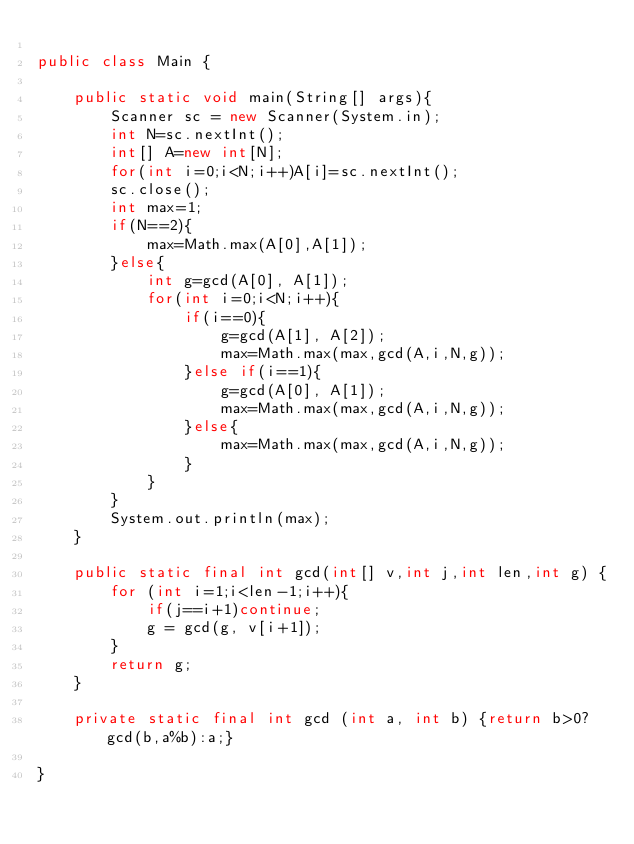<code> <loc_0><loc_0><loc_500><loc_500><_Java_>
public class Main {

	public static void main(String[] args){
		Scanner sc = new Scanner(System.in);
		int N=sc.nextInt();
		int[] A=new int[N];
		for(int i=0;i<N;i++)A[i]=sc.nextInt();
		sc.close();
		int max=1;
		if(N==2){
			max=Math.max(A[0],A[1]);
		}else{
			int g=gcd(A[0], A[1]);
			for(int i=0;i<N;i++){
				if(i==0){
					g=gcd(A[1], A[2]);
					max=Math.max(max,gcd(A,i,N,g));
				}else if(i==1){
					g=gcd(A[0], A[1]);
					max=Math.max(max,gcd(A,i,N,g));
				}else{
					max=Math.max(max,gcd(A,i,N,g));
				}
			}
		}
		System.out.println(max);
	}

	public static final int gcd(int[] v,int j,int len,int g) {
		for (int i=1;i<len-1;i++){
			if(j==i+1)continue;
			g = gcd(g, v[i+1]);
		}
		return g;
	}

	private static final int gcd (int a, int b) {return b>0?gcd(b,a%b):a;}

}</code> 